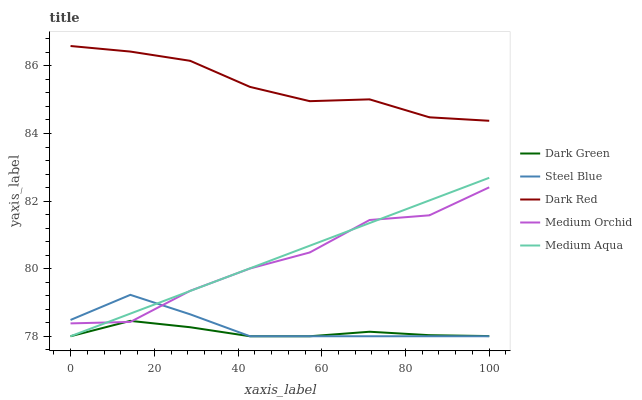Does Dark Green have the minimum area under the curve?
Answer yes or no. Yes. Does Dark Red have the maximum area under the curve?
Answer yes or no. Yes. Does Medium Orchid have the minimum area under the curve?
Answer yes or no. No. Does Medium Orchid have the maximum area under the curve?
Answer yes or no. No. Is Medium Aqua the smoothest?
Answer yes or no. Yes. Is Medium Orchid the roughest?
Answer yes or no. Yes. Is Medium Orchid the smoothest?
Answer yes or no. No. Is Medium Aqua the roughest?
Answer yes or no. No. Does Medium Aqua have the lowest value?
Answer yes or no. Yes. Does Medium Orchid have the lowest value?
Answer yes or no. No. Does Dark Red have the highest value?
Answer yes or no. Yes. Does Medium Orchid have the highest value?
Answer yes or no. No. Is Medium Aqua less than Dark Red?
Answer yes or no. Yes. Is Dark Red greater than Steel Blue?
Answer yes or no. Yes. Does Medium Aqua intersect Steel Blue?
Answer yes or no. Yes. Is Medium Aqua less than Steel Blue?
Answer yes or no. No. Is Medium Aqua greater than Steel Blue?
Answer yes or no. No. Does Medium Aqua intersect Dark Red?
Answer yes or no. No. 